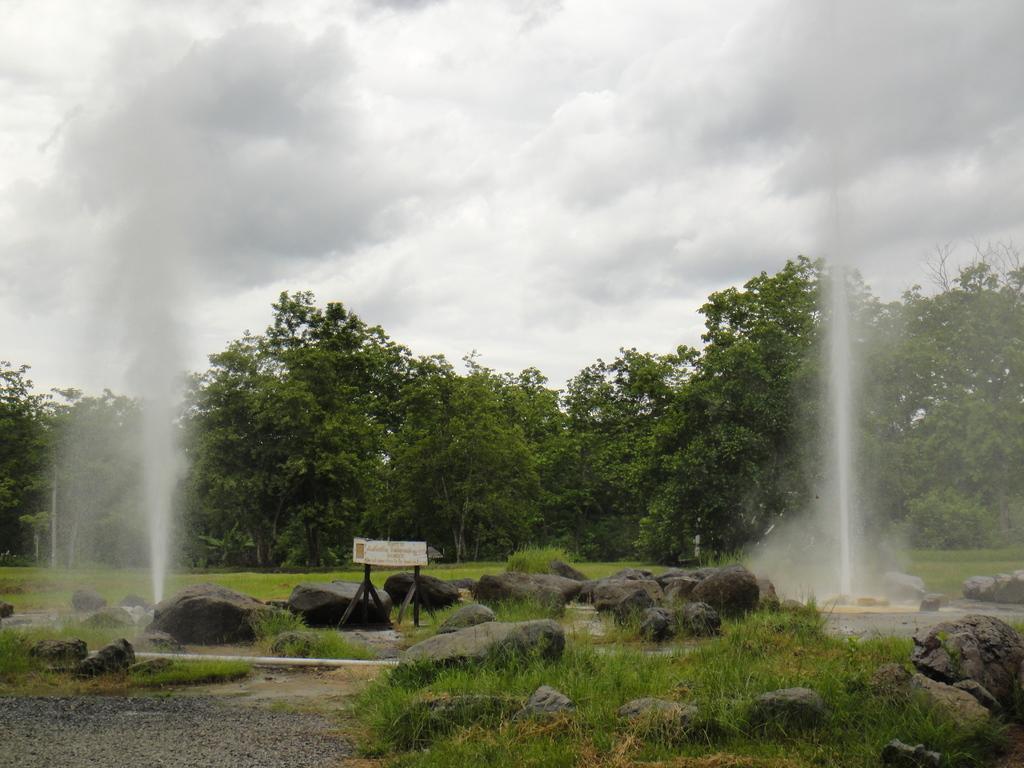Can you describe this image briefly? In this image I can see rocks, grass, board and fountains. There are trees at the back. 